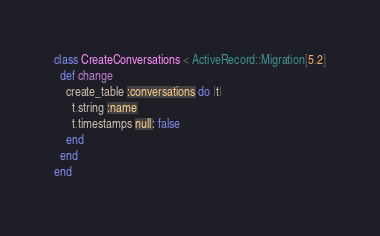<code> <loc_0><loc_0><loc_500><loc_500><_Ruby_>class CreateConversations < ActiveRecord::Migration[5.2]
  def change
    create_table :conversations do |t|
      t.string :name
      t.timestamps null: false
    end
  end
end
</code> 